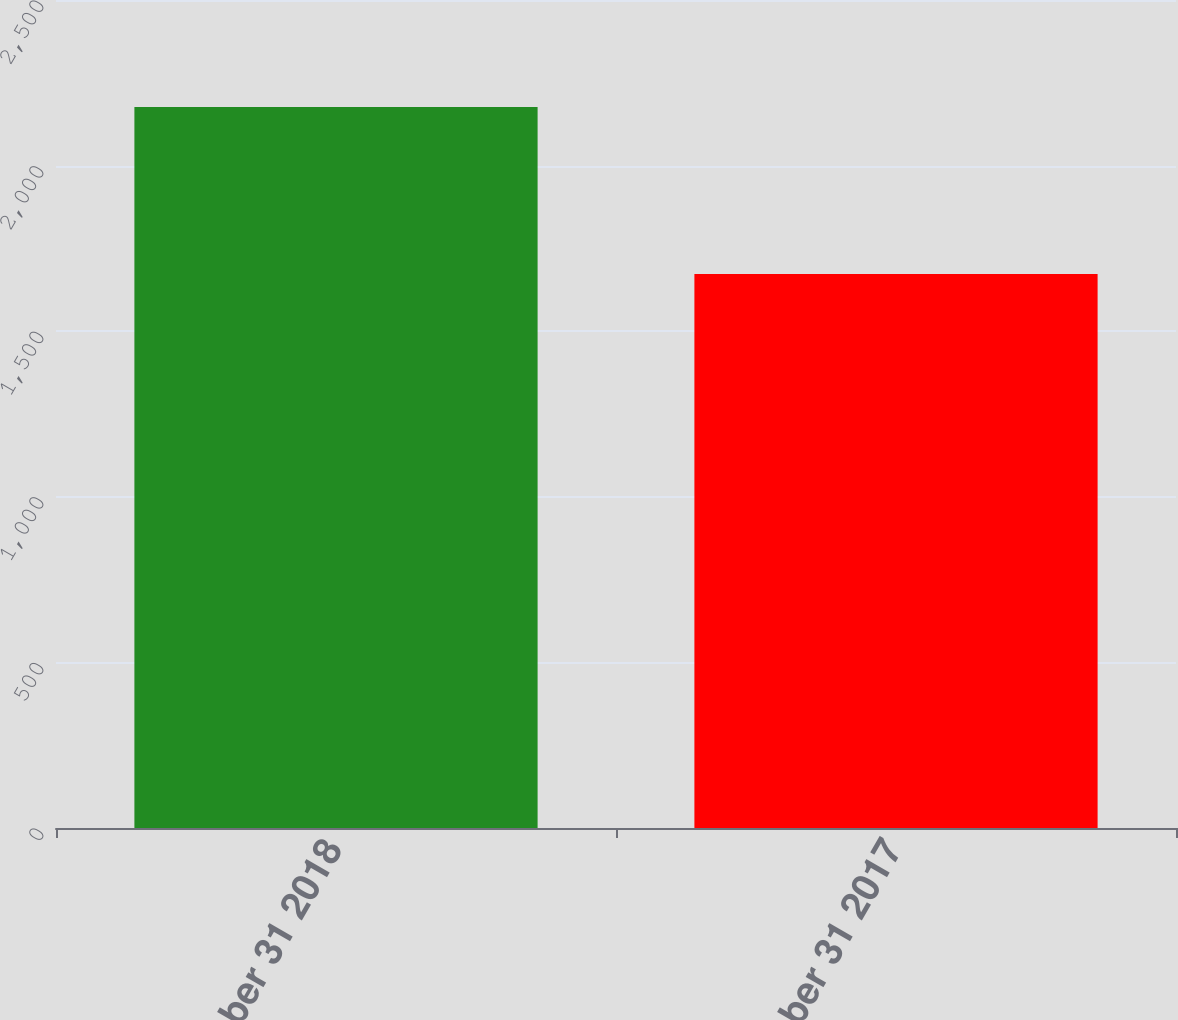<chart> <loc_0><loc_0><loc_500><loc_500><bar_chart><fcel>December 31 2018<fcel>December 31 2017<nl><fcel>2177<fcel>1673<nl></chart> 